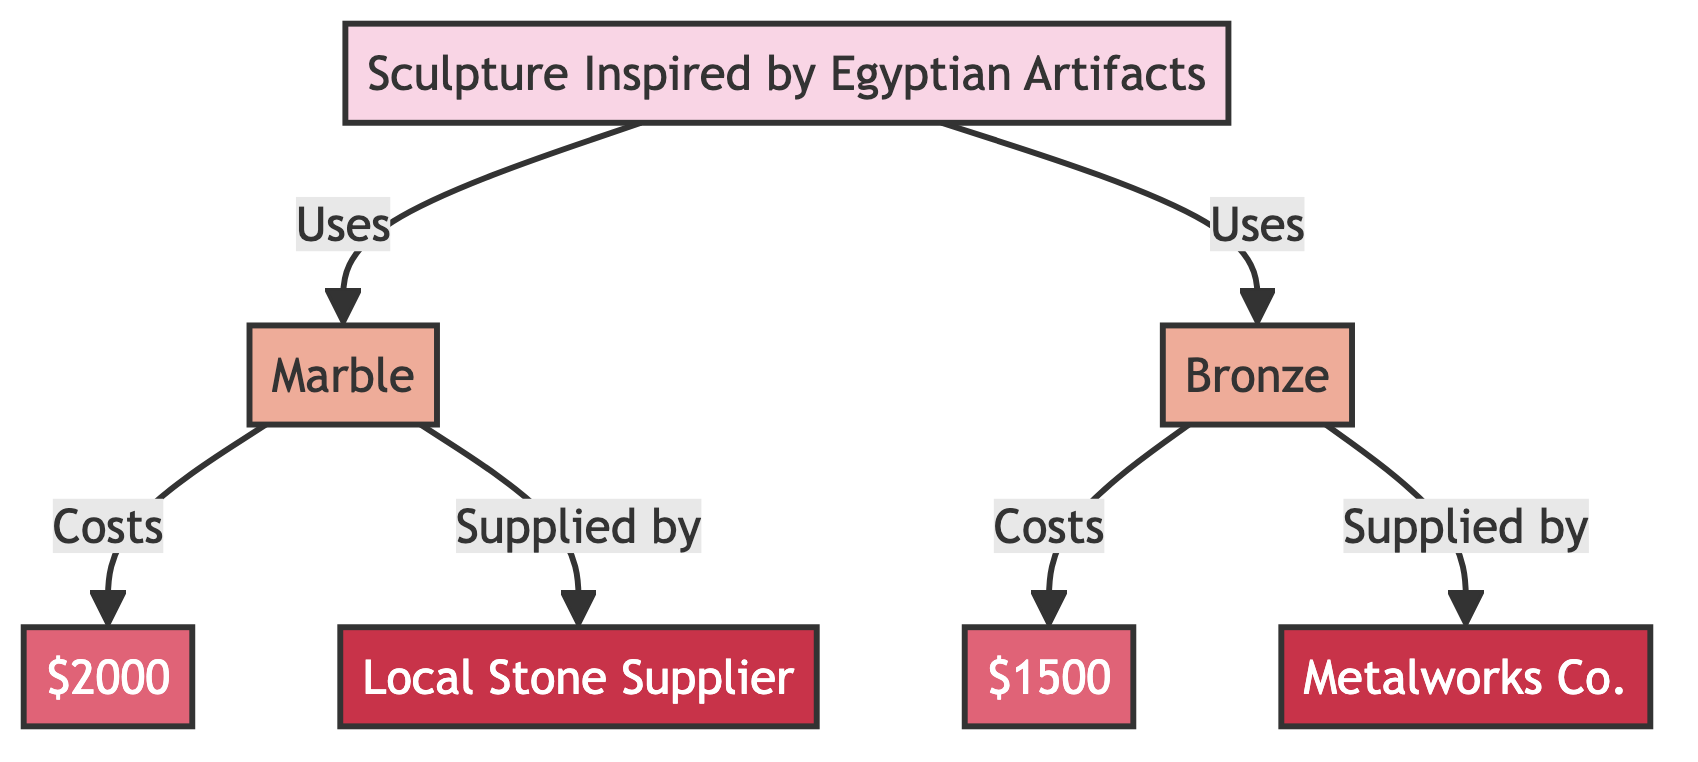What is the total number of nodes in the diagram? The diagram lists 7 distinct nodes: one commissioned piece, two materials, two costs, and two suppliers. Adding these together gives a total of 7 nodes.
Answer: 7 Who supplies the marble used in the commissioned piece? The edge connecting the "Materials_1 (Marble)" node to the "Supplier_1 (Local Stone Supplier)" node indicates that marble is supplied by the local stone supplier.
Answer: Local Stone Supplier What is the cost of the bronze material? The "Materials_2 (Bronze)" node connects to the "Cost_Materials_2 ($1500)" node, showing that the cost associated with the bronze material is $1500.
Answer: $1500 Which commissioned piece uses the bronze material? The "Commissioned_Piece_1 (Sculpture Inspired by Egyptian Artifacts)" node connects to the "Materials_2 (Bronze)" node, indicating that this commissioned piece uses bronze.
Answer: Sculpture Inspired by Egyptian Artifacts What is the combined cost of materials for the commissioned piece? The costs associated with the two materials, $2000 for marble and $1500 for bronze, can be combined: $2000 + $1500 = $3500. This summation provides the total cost of materials for the commissioned piece.
Answer: $3500 What type of diagram is represented here? The structure consists of nodes and directed edges illustrating relationships among components, qualifying it as a directed graph.
Answer: Directed Graph How many suppliers are mentioned in the diagram? There are two distinct suppliers identified in the diagram: "Local Stone Supplier" and "Metalworks Co." Thus, there are a total of 2 suppliers.
Answer: 2 Which material costs more, marble or bronze? The costs are presented as $2000 for marble and $1500 for bronze. Comparing these values shows that marble, at $2000, costs more than bronze, which is $1500.
Answer: Marble 